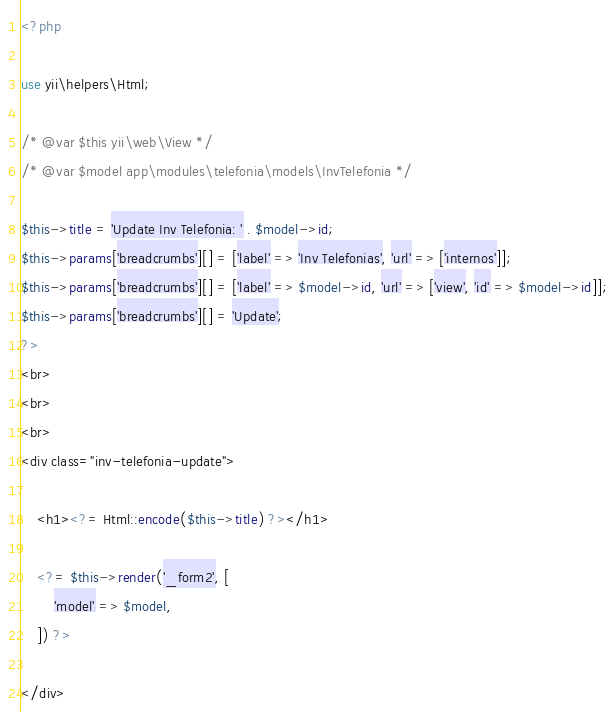<code> <loc_0><loc_0><loc_500><loc_500><_PHP_><?php

use yii\helpers\Html;

/* @var $this yii\web\View */
/* @var $model app\modules\telefonia\models\InvTelefonia */

$this->title = 'Update Inv Telefonia: ' . $model->id;
$this->params['breadcrumbs'][] = ['label' => 'Inv Telefonias', 'url' => ['internos']];
$this->params['breadcrumbs'][] = ['label' => $model->id, 'url' => ['view', 'id' => $model->id]];
$this->params['breadcrumbs'][] = 'Update';
?>
<br>
<br>
<br>
<div class="inv-telefonia-update">

    <h1><?= Html::encode($this->title) ?></h1>

    <?= $this->render('_form2', [
        'model' => $model,
    ]) ?>

</div>
</code> 